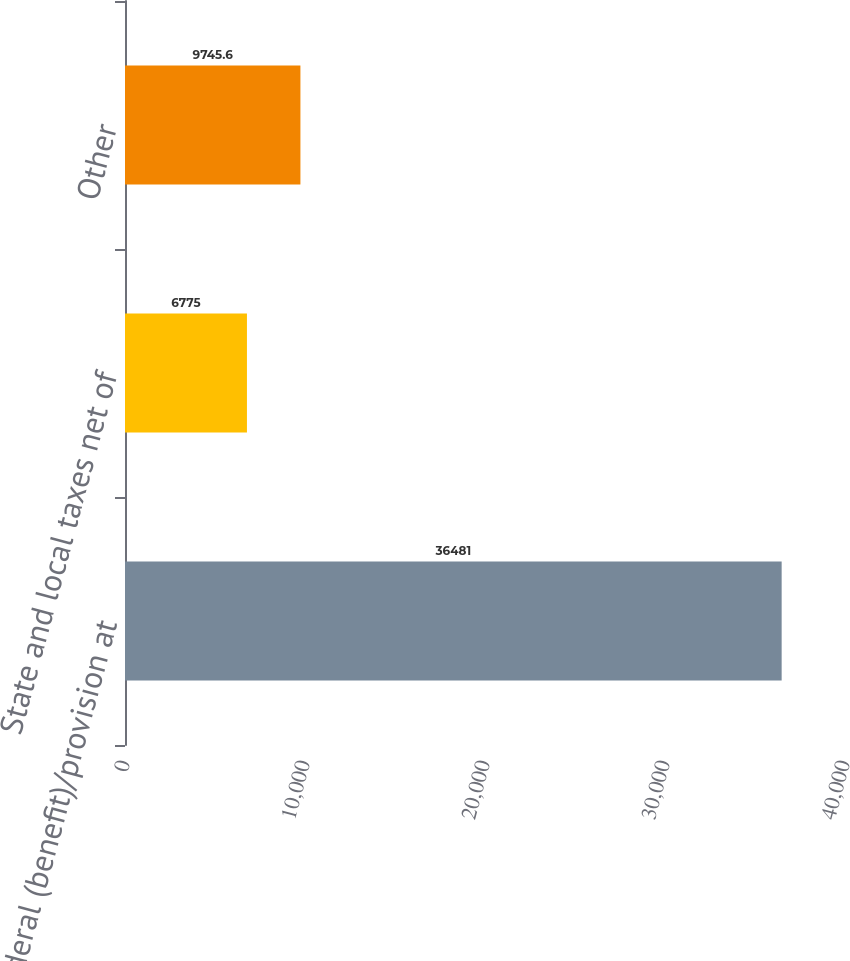<chart> <loc_0><loc_0><loc_500><loc_500><bar_chart><fcel>Federal (benefit)/provision at<fcel>State and local taxes net of<fcel>Other<nl><fcel>36481<fcel>6775<fcel>9745.6<nl></chart> 